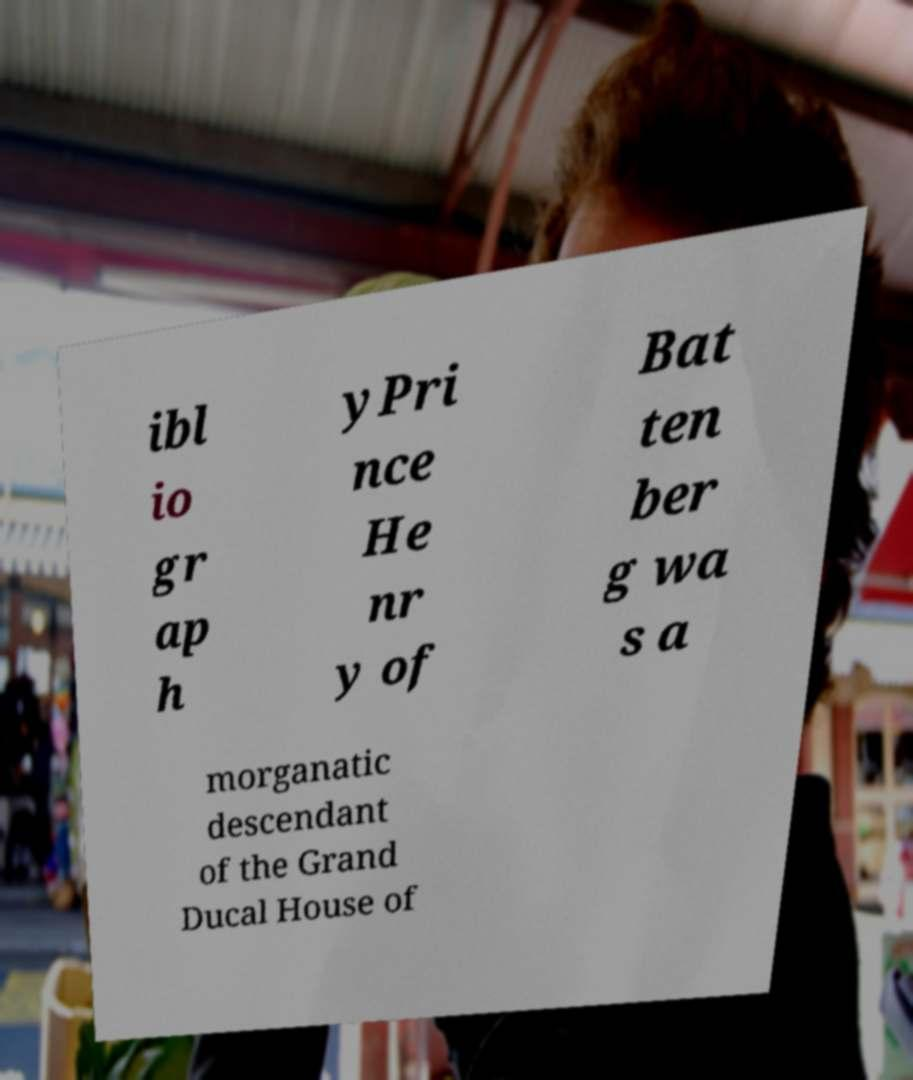What messages or text are displayed in this image? I need them in a readable, typed format. ibl io gr ap h yPri nce He nr y of Bat ten ber g wa s a morganatic descendant of the Grand Ducal House of 